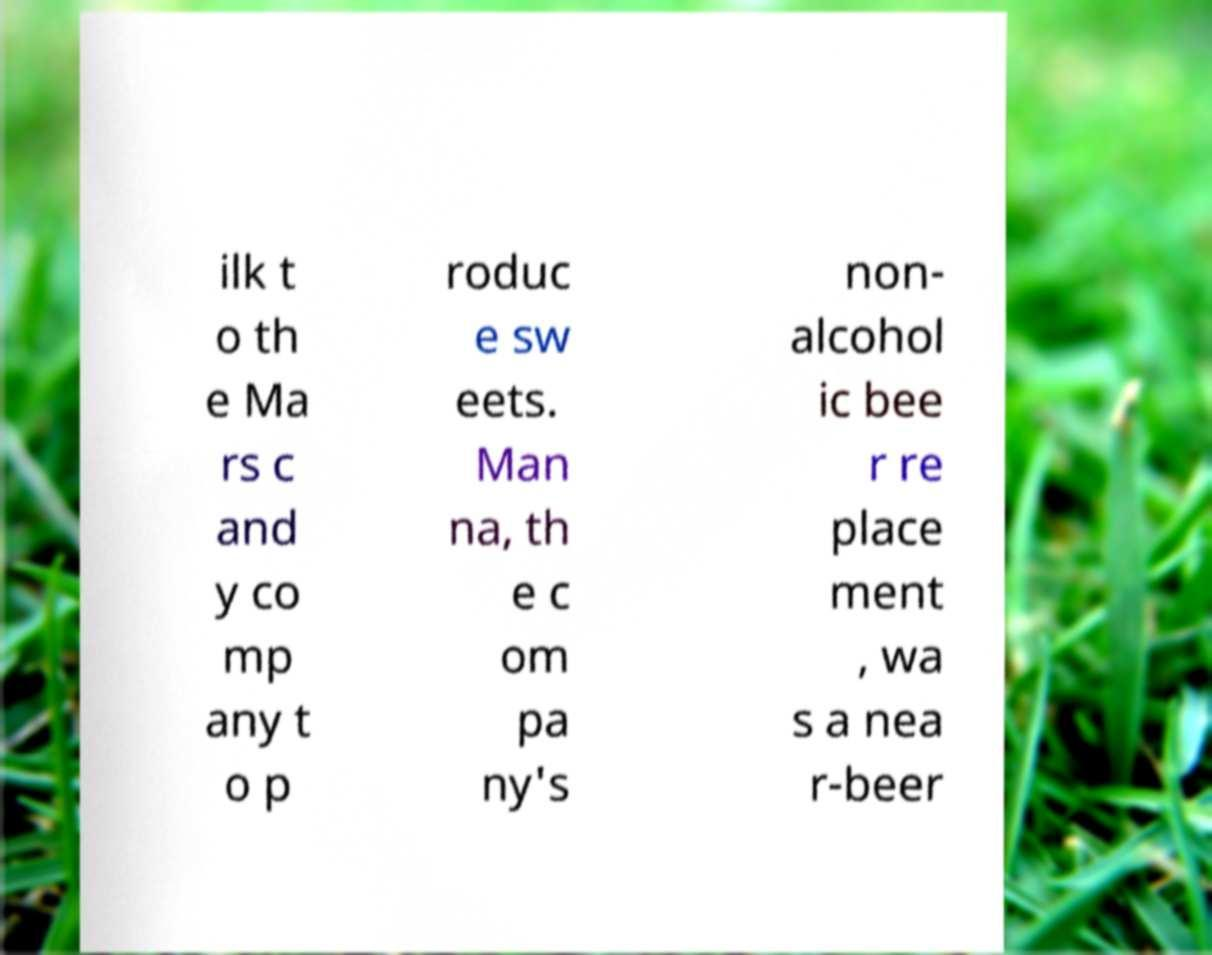Could you extract and type out the text from this image? ilk t o th e Ma rs c and y co mp any t o p roduc e sw eets. Man na, th e c om pa ny's non- alcohol ic bee r re place ment , wa s a nea r-beer 